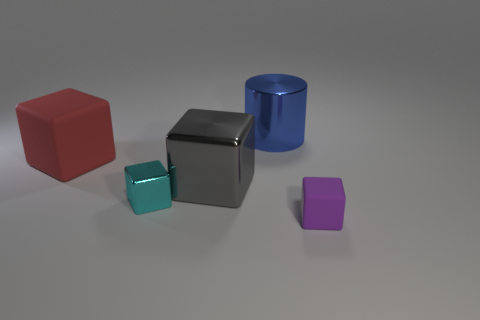How many big metallic cylinders are there?
Give a very brief answer. 1. There is a tiny object in front of the tiny block that is behind the rubber object in front of the red cube; what is it made of?
Offer a terse response. Rubber. What number of tiny cyan blocks are behind the block in front of the tiny metallic object?
Offer a terse response. 1. There is another matte object that is the same shape as the small purple object; what is its color?
Give a very brief answer. Red. Is the material of the cyan thing the same as the red thing?
Ensure brevity in your answer.  No. What number of blocks are either gray metal objects or tiny metallic things?
Your response must be concise. 2. What is the size of the object behind the rubber cube that is behind the tiny cube right of the blue object?
Give a very brief answer. Large. There is another matte object that is the same shape as the small purple object; what is its size?
Your answer should be compact. Large. There is a big gray cube; what number of red matte cubes are right of it?
Provide a short and direct response. 0. Do the big object that is in front of the red rubber object and the big metal cylinder have the same color?
Your answer should be very brief. No. 